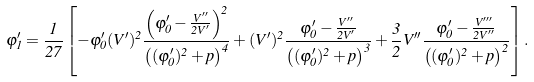<formula> <loc_0><loc_0><loc_500><loc_500>\varphi ^ { \prime } _ { 1 } = \frac { 1 } { 2 7 } \left [ - \varphi ^ { \prime } _ { 0 } ( V ^ { \prime } ) ^ { 2 } \frac { \left ( \varphi ^ { \prime } _ { 0 } - \frac { V ^ { \prime \prime } } { 2 V ^ { \prime } } \right ) ^ { 2 } } { \left ( ( \varphi ^ { \prime } _ { 0 } ) ^ { 2 } + p \right ) ^ { 4 } } + ( V ^ { \prime } ) ^ { 2 } \frac { \varphi ^ { \prime } _ { 0 } - \frac { V ^ { \prime \prime } } { 2 V ^ { \prime } } } { \left ( ( \varphi ^ { \prime } _ { 0 } ) ^ { 2 } + p \right ) ^ { 3 } } + \frac { 3 } { 2 } V ^ { \prime \prime } \frac { \varphi ^ { \prime } _ { 0 } - \frac { V ^ { \prime \prime \prime } } { 2 V ^ { \prime \prime } } } { \left ( ( \varphi ^ { \prime } _ { 0 } ) ^ { 2 } + p \right ) ^ { 2 } } \right ] .</formula> 